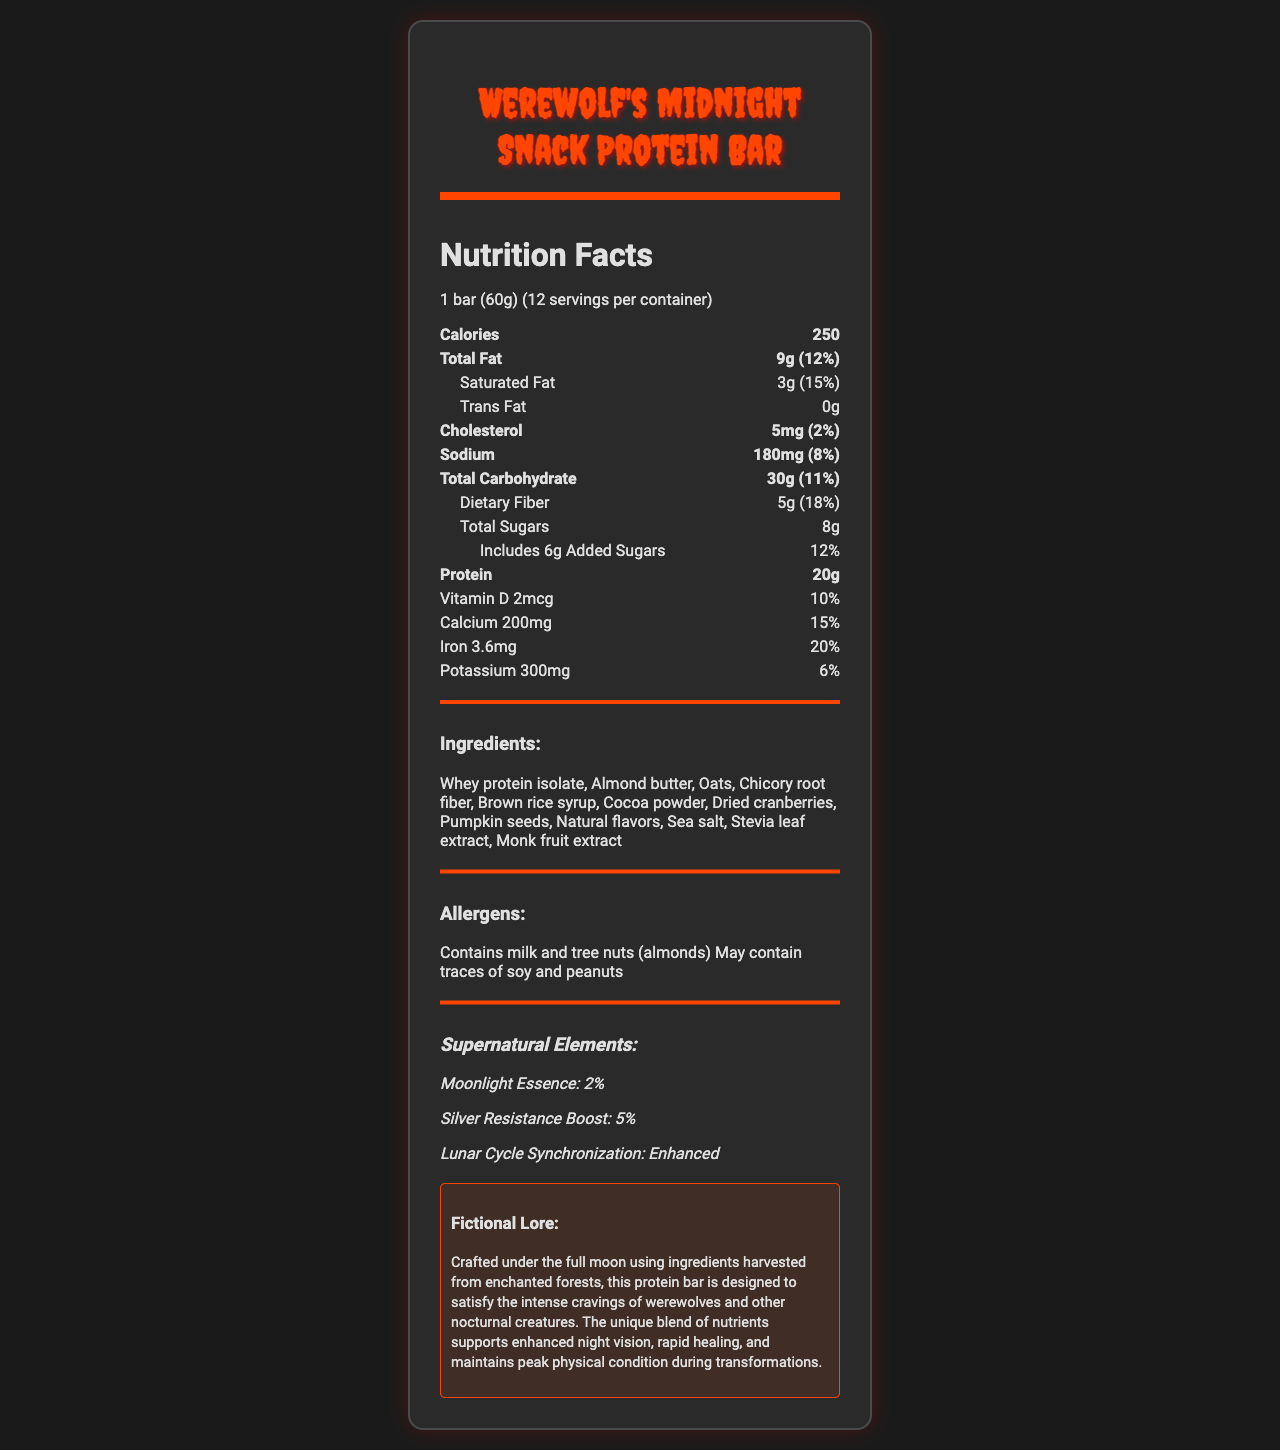what is the serving size of the Werewolf's Midnight Snack Protein Bar? The serving size is mentioned at the top of the nutrition facts section as "1 bar (60g)".
Answer: 1 bar (60g) how many calories are there per serving? The calorie count per serving is listed immediately following the serving size, showing 250 calories.
Answer: 250 what is the total fat content and its daily value percentage? The total fat content is listed as 9 grams, and the daily value percentage is 12%.
Answer: 9g, 12% how much protein does one bar provide? The protein content is clearly stated as 20 grams.
Answer: 20g list two primary allergens in the Werewolf's Midnight Snack Protein Bar. The allergens section lists milk and tree nuts (almonds) as primary allergens.
Answer: Milk and tree nuts (almonds) how many grams of dietary fiber are in one serving? The dietary fiber content is mentioned as 5 grams per serving.
Answer: 5g what percentage of your daily iron intake does one bar provide? A. 10% B. 15% C. 20% D. 25% The nutrition facts indicate that one bar provides 20% of the daily value for iron.
Answer: C which supernatural element is specifically mentioned to provide a boost to silver resistance? A. Moonlight Essence B. Silver Resistance Boost C. Lunar Cycle Synchronization The document specifically mentions "Silver Resistance Boost" as one of the supernatural elements.
Answer: B is there any trans fat in the Werewolf's Midnight Snack Protein Bar? The nutrition facts explicitly state there is 0 grams of trans fat.
Answer: No describe the main idea of the fictional lore in the document. The fictional lore details the unique crafting process and benefits of the protein bar for supernatural and nocturnal beings.
Answer: The protein bar is crafted under the full moon using enchanted ingredients to satisfy cravings of werewolves and nocturnal creatures, supporting enhanced night vision, rapid healing, and maintaining peak physical condition during transformations. what are the benefits of lunar cycle synchronization mentioned in the document? The document mentions lunar cycle synchronization is enhanced but does not provide specific benefits.
Answer: Not enough information how many grams of sugars are added to the Werewolf's Midnight Snack Protein Bar? The amount of added sugars is noted as 6 grams.
Answer: 6g which ingredient is not part of the Werewolf's Midnight Snack Protein Bar? A. Almond butter B. Whey protein isolate C. Honey D. Chicory root fiber Honey is not listed in the ingredients section, while almond butter, whey protein isolate, and chicory root fiber are mentioned.
Answer: C is the protein bar designed to support enhanced night vision? The fictional lore section specifically mentions that the protein bar supports enhanced night vision for nocturnal creatures.
Answer: Yes 